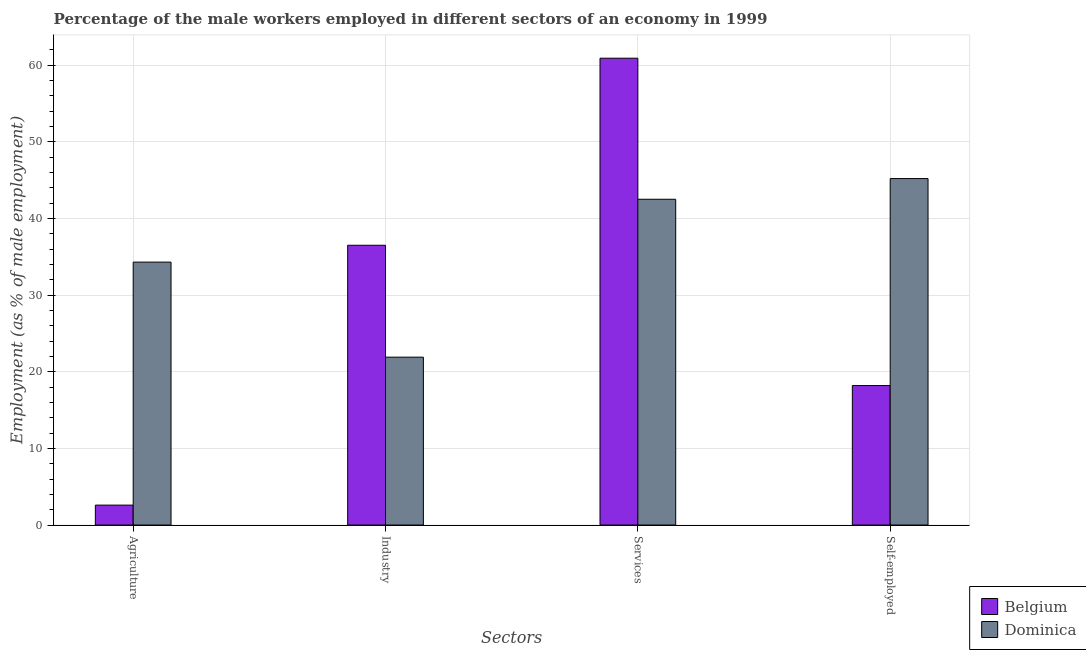How many different coloured bars are there?
Offer a very short reply. 2. What is the label of the 3rd group of bars from the left?
Your answer should be very brief. Services. What is the percentage of male workers in agriculture in Belgium?
Offer a very short reply. 2.6. Across all countries, what is the maximum percentage of male workers in industry?
Give a very brief answer. 36.5. Across all countries, what is the minimum percentage of male workers in agriculture?
Keep it short and to the point. 2.6. In which country was the percentage of male workers in agriculture minimum?
Offer a very short reply. Belgium. What is the total percentage of male workers in agriculture in the graph?
Keep it short and to the point. 36.9. What is the difference between the percentage of male workers in industry in Dominica and that in Belgium?
Give a very brief answer. -14.6. What is the difference between the percentage of male workers in agriculture in Belgium and the percentage of male workers in industry in Dominica?
Give a very brief answer. -19.3. What is the average percentage of male workers in services per country?
Make the answer very short. 51.7. What is the difference between the percentage of male workers in industry and percentage of self employed male workers in Dominica?
Make the answer very short. -23.3. What is the ratio of the percentage of male workers in services in Dominica to that in Belgium?
Make the answer very short. 0.7. Is the difference between the percentage of male workers in services in Belgium and Dominica greater than the difference between the percentage of male workers in industry in Belgium and Dominica?
Offer a very short reply. Yes. What is the difference between the highest and the second highest percentage of male workers in agriculture?
Your answer should be compact. 31.7. What is the difference between the highest and the lowest percentage of male workers in services?
Your answer should be very brief. 18.4. In how many countries, is the percentage of male workers in agriculture greater than the average percentage of male workers in agriculture taken over all countries?
Offer a terse response. 1. Is it the case that in every country, the sum of the percentage of self employed male workers and percentage of male workers in industry is greater than the sum of percentage of male workers in services and percentage of male workers in agriculture?
Your answer should be compact. No. What does the 2nd bar from the left in Agriculture represents?
Give a very brief answer. Dominica. Is it the case that in every country, the sum of the percentage of male workers in agriculture and percentage of male workers in industry is greater than the percentage of male workers in services?
Provide a succinct answer. No. How many bars are there?
Provide a succinct answer. 8. Are all the bars in the graph horizontal?
Keep it short and to the point. No. What is the difference between two consecutive major ticks on the Y-axis?
Make the answer very short. 10. Are the values on the major ticks of Y-axis written in scientific E-notation?
Ensure brevity in your answer.  No. Does the graph contain grids?
Provide a succinct answer. Yes. Where does the legend appear in the graph?
Offer a terse response. Bottom right. What is the title of the graph?
Give a very brief answer. Percentage of the male workers employed in different sectors of an economy in 1999. Does "Europe(all income levels)" appear as one of the legend labels in the graph?
Offer a very short reply. No. What is the label or title of the X-axis?
Provide a succinct answer. Sectors. What is the label or title of the Y-axis?
Ensure brevity in your answer.  Employment (as % of male employment). What is the Employment (as % of male employment) of Belgium in Agriculture?
Your response must be concise. 2.6. What is the Employment (as % of male employment) of Dominica in Agriculture?
Make the answer very short. 34.3. What is the Employment (as % of male employment) in Belgium in Industry?
Ensure brevity in your answer.  36.5. What is the Employment (as % of male employment) in Dominica in Industry?
Make the answer very short. 21.9. What is the Employment (as % of male employment) of Belgium in Services?
Give a very brief answer. 60.9. What is the Employment (as % of male employment) of Dominica in Services?
Provide a short and direct response. 42.5. What is the Employment (as % of male employment) in Belgium in Self-employed?
Provide a succinct answer. 18.2. What is the Employment (as % of male employment) in Dominica in Self-employed?
Provide a succinct answer. 45.2. Across all Sectors, what is the maximum Employment (as % of male employment) in Belgium?
Your response must be concise. 60.9. Across all Sectors, what is the maximum Employment (as % of male employment) in Dominica?
Make the answer very short. 45.2. Across all Sectors, what is the minimum Employment (as % of male employment) of Belgium?
Keep it short and to the point. 2.6. Across all Sectors, what is the minimum Employment (as % of male employment) of Dominica?
Keep it short and to the point. 21.9. What is the total Employment (as % of male employment) of Belgium in the graph?
Ensure brevity in your answer.  118.2. What is the total Employment (as % of male employment) in Dominica in the graph?
Offer a terse response. 143.9. What is the difference between the Employment (as % of male employment) of Belgium in Agriculture and that in Industry?
Your answer should be compact. -33.9. What is the difference between the Employment (as % of male employment) of Dominica in Agriculture and that in Industry?
Provide a short and direct response. 12.4. What is the difference between the Employment (as % of male employment) in Belgium in Agriculture and that in Services?
Offer a terse response. -58.3. What is the difference between the Employment (as % of male employment) in Belgium in Agriculture and that in Self-employed?
Your response must be concise. -15.6. What is the difference between the Employment (as % of male employment) in Dominica in Agriculture and that in Self-employed?
Ensure brevity in your answer.  -10.9. What is the difference between the Employment (as % of male employment) in Belgium in Industry and that in Services?
Make the answer very short. -24.4. What is the difference between the Employment (as % of male employment) in Dominica in Industry and that in Services?
Offer a terse response. -20.6. What is the difference between the Employment (as % of male employment) in Belgium in Industry and that in Self-employed?
Provide a short and direct response. 18.3. What is the difference between the Employment (as % of male employment) in Dominica in Industry and that in Self-employed?
Offer a terse response. -23.3. What is the difference between the Employment (as % of male employment) of Belgium in Services and that in Self-employed?
Your answer should be very brief. 42.7. What is the difference between the Employment (as % of male employment) of Dominica in Services and that in Self-employed?
Make the answer very short. -2.7. What is the difference between the Employment (as % of male employment) of Belgium in Agriculture and the Employment (as % of male employment) of Dominica in Industry?
Your response must be concise. -19.3. What is the difference between the Employment (as % of male employment) of Belgium in Agriculture and the Employment (as % of male employment) of Dominica in Services?
Your response must be concise. -39.9. What is the difference between the Employment (as % of male employment) of Belgium in Agriculture and the Employment (as % of male employment) of Dominica in Self-employed?
Keep it short and to the point. -42.6. What is the difference between the Employment (as % of male employment) in Belgium in Industry and the Employment (as % of male employment) in Dominica in Self-employed?
Offer a terse response. -8.7. What is the difference between the Employment (as % of male employment) of Belgium in Services and the Employment (as % of male employment) of Dominica in Self-employed?
Give a very brief answer. 15.7. What is the average Employment (as % of male employment) in Belgium per Sectors?
Provide a short and direct response. 29.55. What is the average Employment (as % of male employment) of Dominica per Sectors?
Offer a terse response. 35.98. What is the difference between the Employment (as % of male employment) in Belgium and Employment (as % of male employment) in Dominica in Agriculture?
Give a very brief answer. -31.7. What is the difference between the Employment (as % of male employment) of Belgium and Employment (as % of male employment) of Dominica in Services?
Offer a very short reply. 18.4. What is the difference between the Employment (as % of male employment) of Belgium and Employment (as % of male employment) of Dominica in Self-employed?
Your answer should be compact. -27. What is the ratio of the Employment (as % of male employment) in Belgium in Agriculture to that in Industry?
Provide a succinct answer. 0.07. What is the ratio of the Employment (as % of male employment) in Dominica in Agriculture to that in Industry?
Make the answer very short. 1.57. What is the ratio of the Employment (as % of male employment) in Belgium in Agriculture to that in Services?
Offer a very short reply. 0.04. What is the ratio of the Employment (as % of male employment) in Dominica in Agriculture to that in Services?
Make the answer very short. 0.81. What is the ratio of the Employment (as % of male employment) in Belgium in Agriculture to that in Self-employed?
Ensure brevity in your answer.  0.14. What is the ratio of the Employment (as % of male employment) of Dominica in Agriculture to that in Self-employed?
Your response must be concise. 0.76. What is the ratio of the Employment (as % of male employment) in Belgium in Industry to that in Services?
Give a very brief answer. 0.6. What is the ratio of the Employment (as % of male employment) in Dominica in Industry to that in Services?
Provide a succinct answer. 0.52. What is the ratio of the Employment (as % of male employment) in Belgium in Industry to that in Self-employed?
Your answer should be very brief. 2.01. What is the ratio of the Employment (as % of male employment) of Dominica in Industry to that in Self-employed?
Offer a very short reply. 0.48. What is the ratio of the Employment (as % of male employment) in Belgium in Services to that in Self-employed?
Ensure brevity in your answer.  3.35. What is the ratio of the Employment (as % of male employment) in Dominica in Services to that in Self-employed?
Your answer should be very brief. 0.94. What is the difference between the highest and the second highest Employment (as % of male employment) in Belgium?
Offer a very short reply. 24.4. What is the difference between the highest and the lowest Employment (as % of male employment) of Belgium?
Offer a very short reply. 58.3. What is the difference between the highest and the lowest Employment (as % of male employment) in Dominica?
Ensure brevity in your answer.  23.3. 